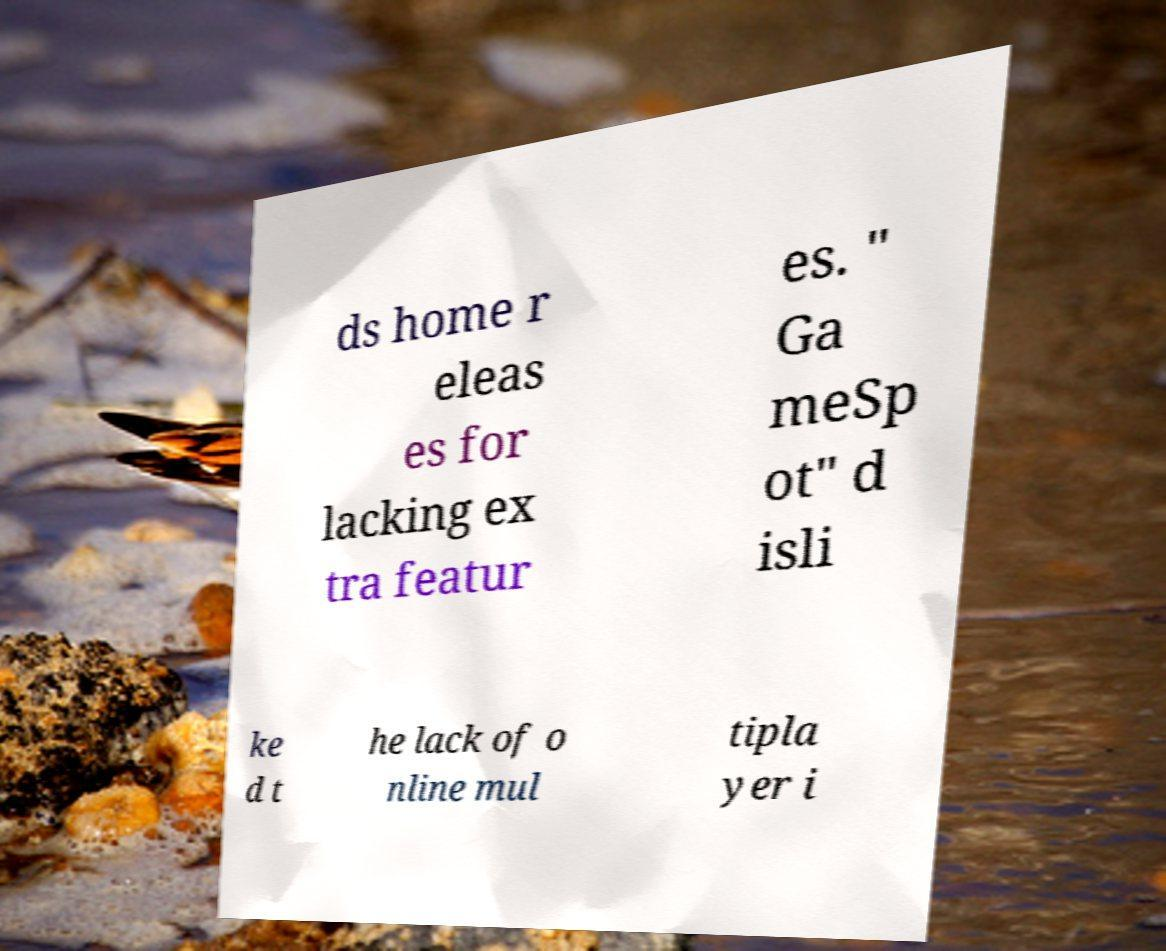Please identify and transcribe the text found in this image. ds home r eleas es for lacking ex tra featur es. " Ga meSp ot" d isli ke d t he lack of o nline mul tipla yer i 